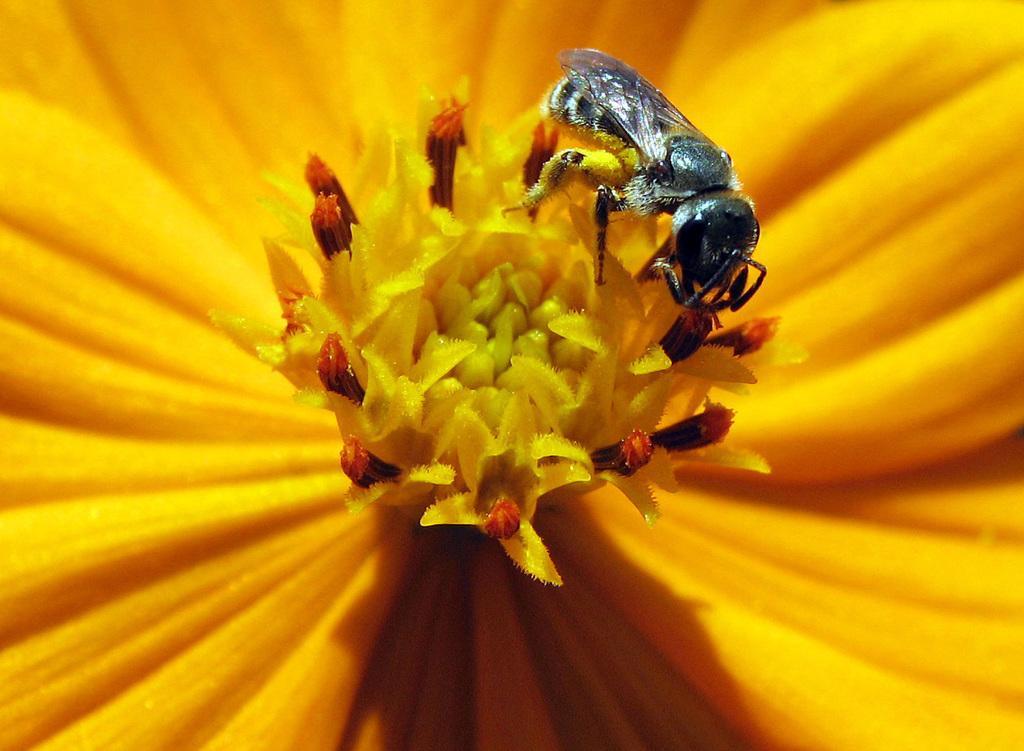How would you summarize this image in a sentence or two? Here we can see an insect on a flower. 